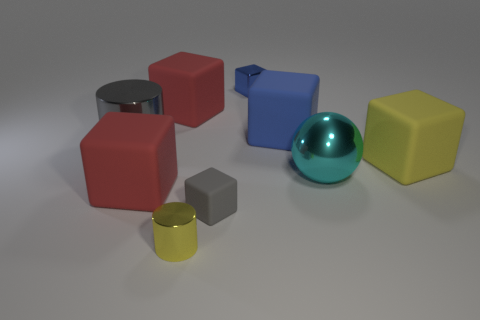There is a big metal thing left of the blue cube that is behind the blue thing in front of the tiny blue block; what is its color?
Keep it short and to the point. Gray. There is a small metallic object that is in front of the big rubber object to the right of the large cyan metallic thing; what is its shape?
Your response must be concise. Cylinder. Is the number of large blue rubber blocks to the left of the small rubber cube greater than the number of cyan metallic spheres?
Give a very brief answer. No. There is a tiny gray thing that is in front of the large metal cylinder; is it the same shape as the big gray shiny thing?
Give a very brief answer. No. Are there any small gray matte things of the same shape as the large yellow matte thing?
Your answer should be very brief. Yes. What number of objects are yellow things that are on the right side of the blue shiny cube or brown rubber blocks?
Give a very brief answer. 1. Are there more gray balls than gray blocks?
Ensure brevity in your answer.  No. Is there a gray matte object that has the same size as the gray block?
Ensure brevity in your answer.  No. How many things are large blocks to the left of the cyan ball or big metallic things that are on the right side of the blue metallic block?
Offer a very short reply. 4. The cylinder that is in front of the metal cylinder behind the tiny yellow cylinder is what color?
Your answer should be very brief. Yellow. 